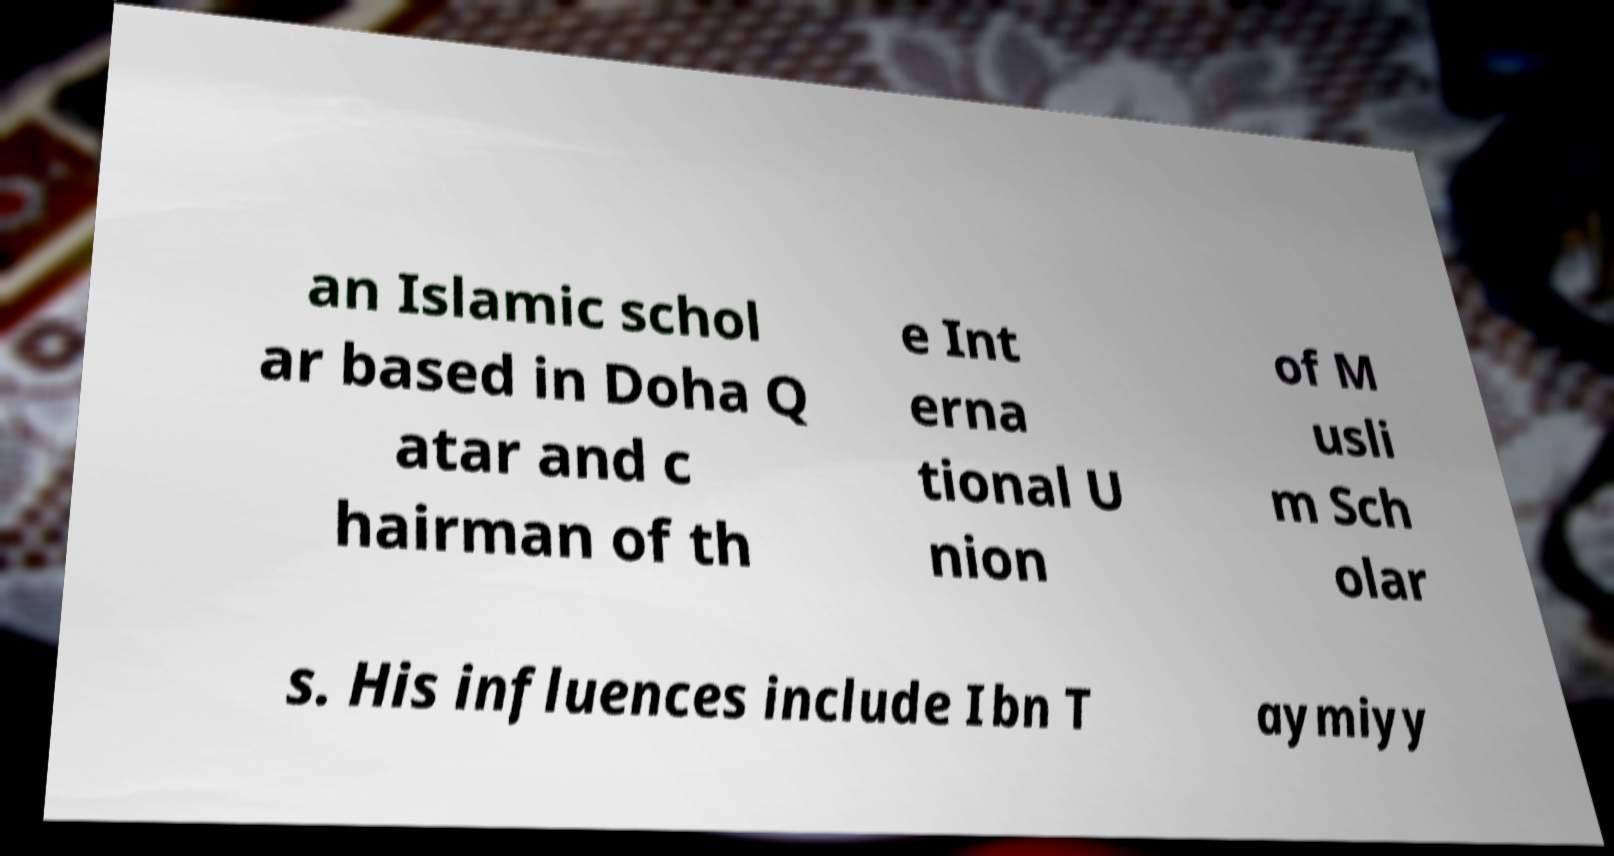Please identify and transcribe the text found in this image. an Islamic schol ar based in Doha Q atar and c hairman of th e Int erna tional U nion of M usli m Sch olar s. His influences include Ibn T aymiyy 